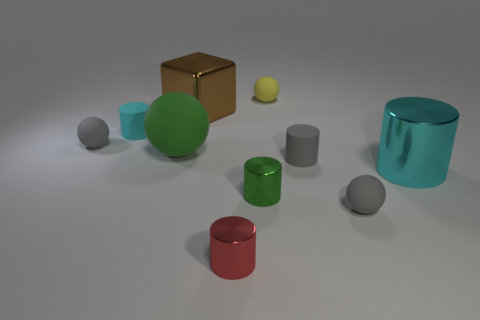The cube is what color?
Offer a terse response. Brown. Are there any small gray things that are in front of the gray rubber thing that is left of the small green thing?
Your answer should be compact. Yes. What is the material of the large cyan thing?
Your answer should be very brief. Metal. Is the material of the tiny thing that is behind the large brown metal thing the same as the gray ball in front of the tiny green cylinder?
Offer a terse response. Yes. Is there anything else that has the same color as the cube?
Your answer should be very brief. No. There is another tiny metal object that is the same shape as the small red metallic thing; what color is it?
Offer a very short reply. Green. There is a gray matte thing that is both behind the small green metal cylinder and to the right of the green matte sphere; what size is it?
Offer a terse response. Small. There is a green object that is in front of the green matte ball; is its shape the same as the small gray rubber object that is behind the green rubber ball?
Give a very brief answer. No. There is a metal thing that is the same color as the big matte sphere; what is its shape?
Offer a very short reply. Cylinder. What number of objects are the same material as the small yellow ball?
Keep it short and to the point. 5. 